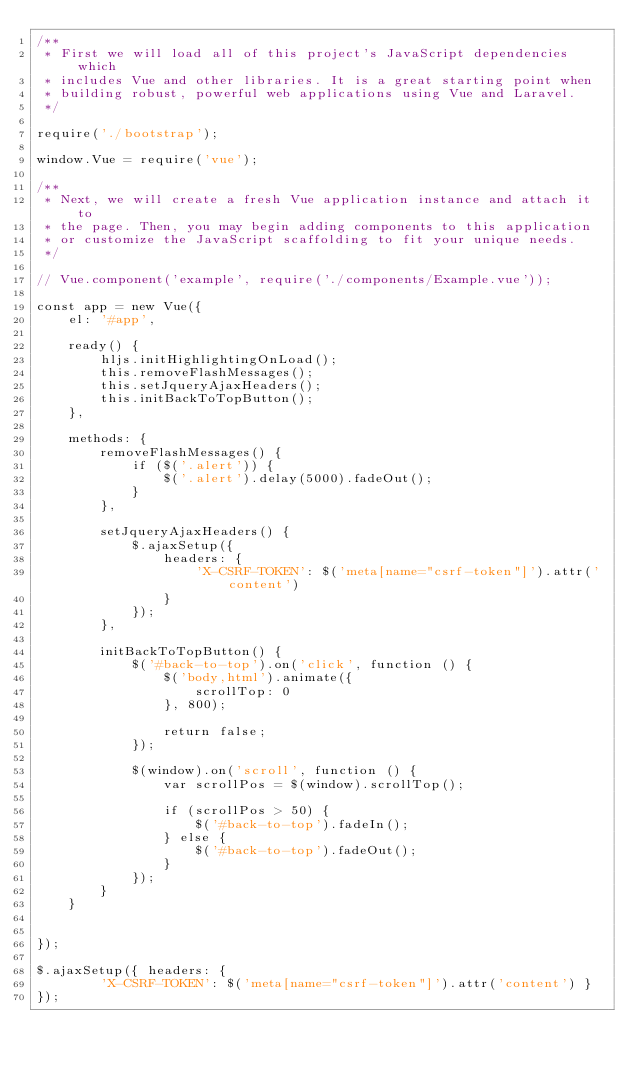<code> <loc_0><loc_0><loc_500><loc_500><_JavaScript_>/**
 * First we will load all of this project's JavaScript dependencies which
 * includes Vue and other libraries. It is a great starting point when
 * building robust, powerful web applications using Vue and Laravel.
 */

require('./bootstrap');

window.Vue = require('vue');

/**
 * Next, we will create a fresh Vue application instance and attach it to
 * the page. Then, you may begin adding components to this application
 * or customize the JavaScript scaffolding to fit your unique needs.
 */

// Vue.component('example', require('./components/Example.vue'));

const app = new Vue({
    el: '#app',

    ready() {
        hljs.initHighlightingOnLoad();
        this.removeFlashMessages();
        this.setJqueryAjaxHeaders();
        this.initBackToTopButton();
    },

    methods: {
        removeFlashMessages() {
            if ($('.alert')) {
                $('.alert').delay(5000).fadeOut();
            }
        },

        setJqueryAjaxHeaders() {
            $.ajaxSetup({
                headers: {
                    'X-CSRF-TOKEN': $('meta[name="csrf-token"]').attr('content')
                }
            });
        },

        initBackToTopButton() {
            $('#back-to-top').on('click', function () {
                $('body,html').animate({
                    scrollTop: 0
                }, 800);

                return false;
            });

            $(window).on('scroll', function () {
                var scrollPos = $(window).scrollTop();

                if (scrollPos > 50) {
                    $('#back-to-top').fadeIn();
                } else {
                    $('#back-to-top').fadeOut();
                }
            });
        }
    }


});

$.ajaxSetup({ headers: {
        'X-CSRF-TOKEN': $('meta[name="csrf-token"]').attr('content') }
});</code> 